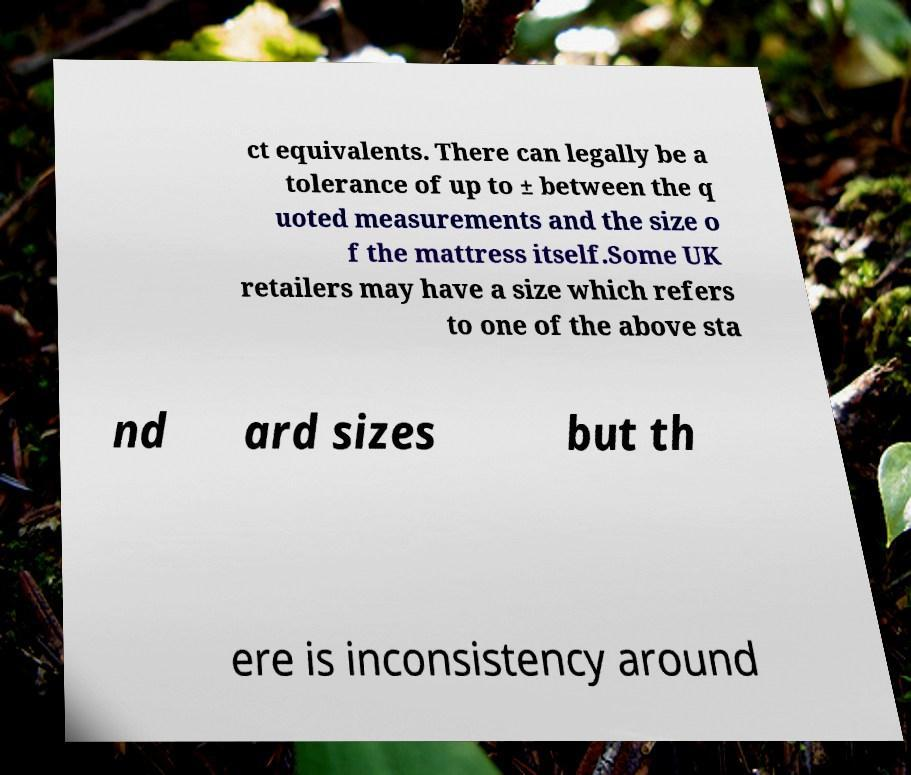Please read and relay the text visible in this image. What does it say? ct equivalents. There can legally be a tolerance of up to ± between the q uoted measurements and the size o f the mattress itself.Some UK retailers may have a size which refers to one of the above sta nd ard sizes but th ere is inconsistency around 